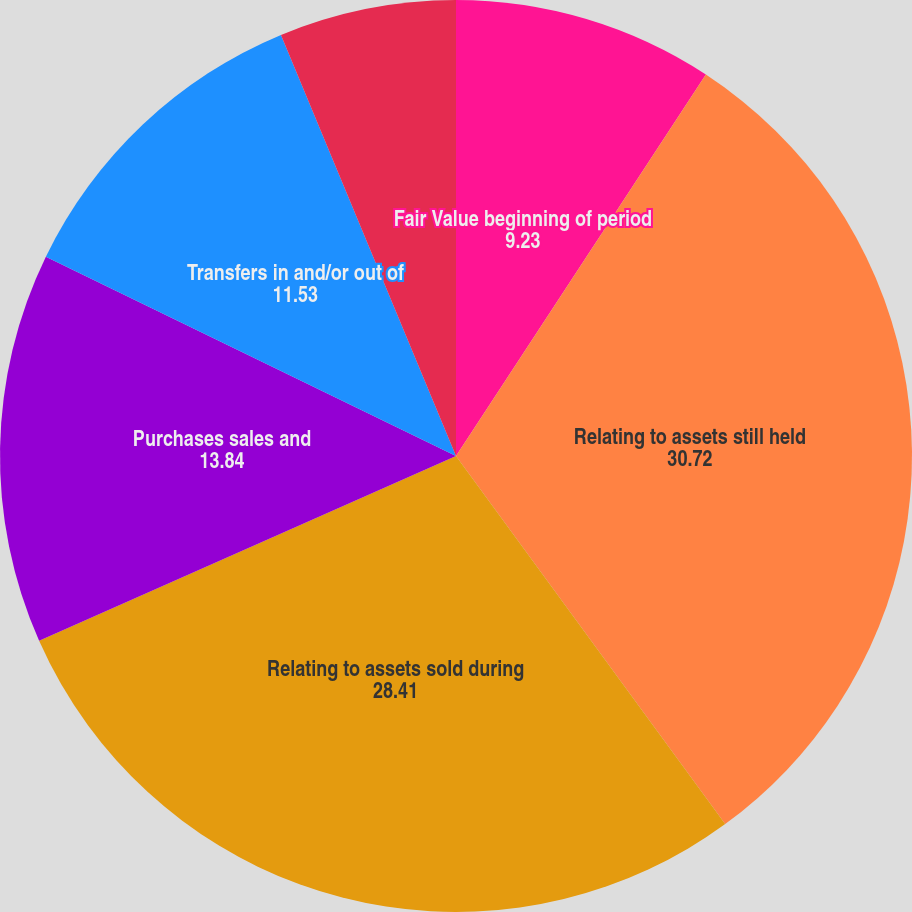<chart> <loc_0><loc_0><loc_500><loc_500><pie_chart><fcel>Fair Value beginning of period<fcel>Relating to assets still held<fcel>Relating to assets sold during<fcel>Purchases sales and<fcel>Transfers in and/or out of<fcel>Fair Value end of period<nl><fcel>9.23%<fcel>30.72%<fcel>28.41%<fcel>13.84%<fcel>11.53%<fcel>6.27%<nl></chart> 